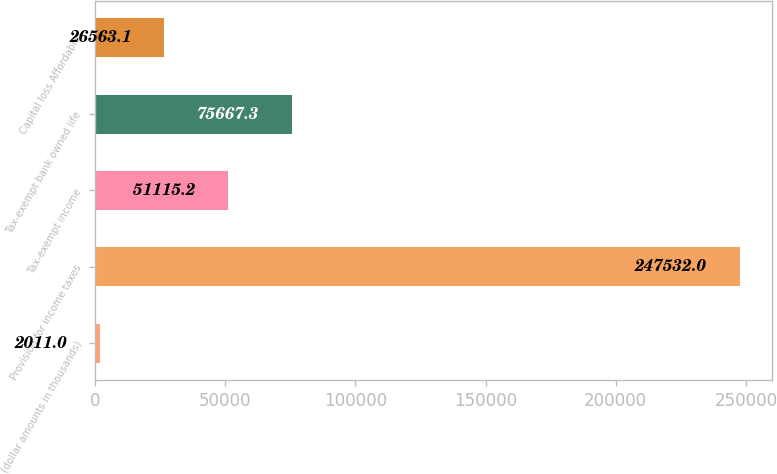Convert chart. <chart><loc_0><loc_0><loc_500><loc_500><bar_chart><fcel>(dollar amounts in thousands)<fcel>Provision for income taxes<fcel>Tax-exempt income<fcel>Tax-exempt bank owned life<fcel>Capital loss Affordable<nl><fcel>2011<fcel>247532<fcel>51115.2<fcel>75667.3<fcel>26563.1<nl></chart> 